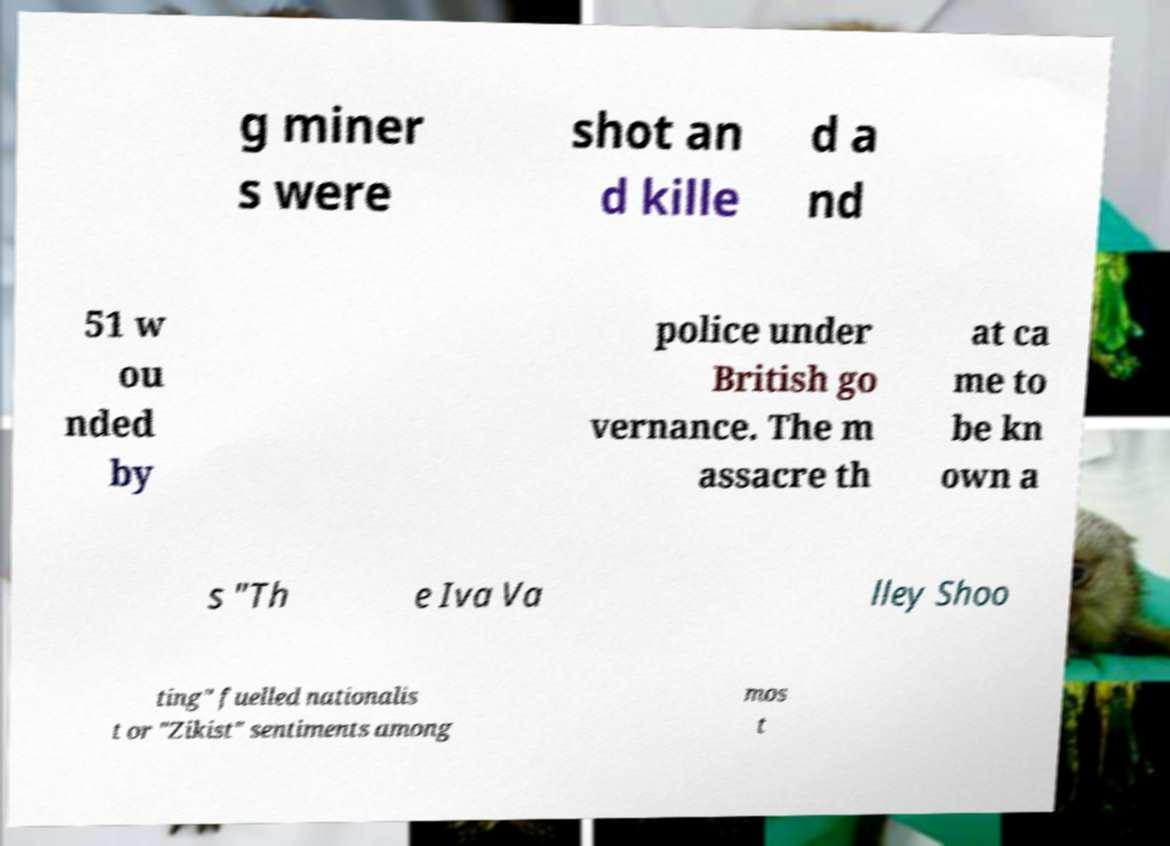What messages or text are displayed in this image? I need them in a readable, typed format. g miner s were shot an d kille d a nd 51 w ou nded by police under British go vernance. The m assacre th at ca me to be kn own a s "Th e Iva Va lley Shoo ting" fuelled nationalis t or "Zikist" sentiments among mos t 